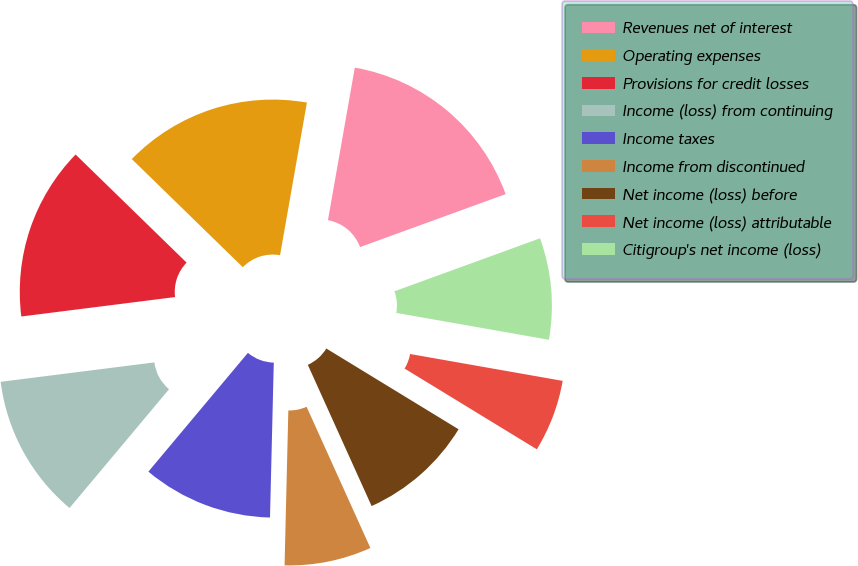Convert chart to OTSL. <chart><loc_0><loc_0><loc_500><loc_500><pie_chart><fcel>Revenues net of interest<fcel>Operating expenses<fcel>Provisions for credit losses<fcel>Income (loss) from continuing<fcel>Income taxes<fcel>Income from discontinued<fcel>Net income (loss) before<fcel>Net income (loss) attributable<fcel>Citigroup's net income (loss)<nl><fcel>16.67%<fcel>15.48%<fcel>14.29%<fcel>11.9%<fcel>10.71%<fcel>7.14%<fcel>9.52%<fcel>5.95%<fcel>8.33%<nl></chart> 